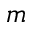<formula> <loc_0><loc_0><loc_500><loc_500>m</formula> 